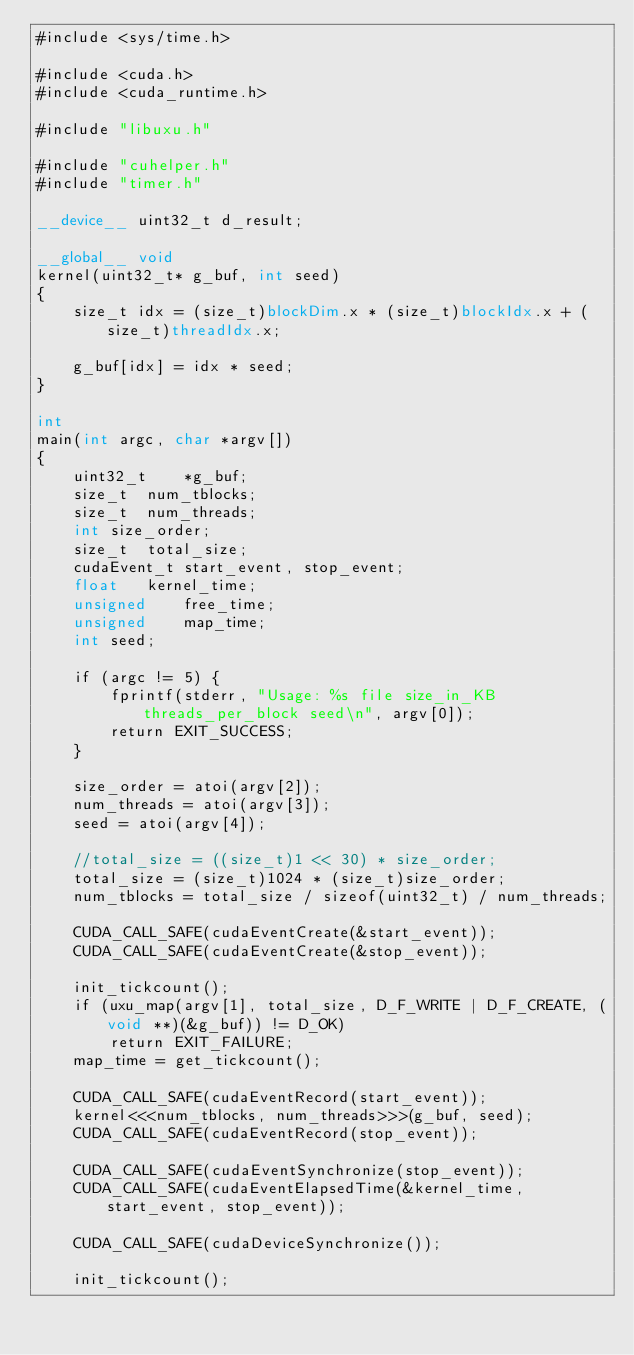<code> <loc_0><loc_0><loc_500><loc_500><_Cuda_>#include <sys/time.h>

#include <cuda.h>
#include <cuda_runtime.h>

#include "libuxu.h"

#include "cuhelper.h"
#include "timer.h"

__device__ uint32_t d_result;

__global__ void
kernel(uint32_t* g_buf, int seed) 
{
	size_t idx = (size_t)blockDim.x * (size_t)blockIdx.x + (size_t)threadIdx.x;

	g_buf[idx] = idx * seed;
}

int
main(int argc, char *argv[])
{
	uint32_t	*g_buf;
	size_t	num_tblocks;          
	size_t	num_threads;          
	int	size_order;
	size_t	total_size;
	cudaEvent_t	start_event, stop_event;
	float	kernel_time;
	unsigned	free_time;
	unsigned	map_time;
	int	seed;

	if (argc != 5) {
		fprintf(stderr, "Usage: %s file size_in_KB threads_per_block seed\n", argv[0]);
		return EXIT_SUCCESS;
	}

	size_order = atoi(argv[2]);
	num_threads = atoi(argv[3]);
	seed = atoi(argv[4]);
    
	//total_size = ((size_t)1 << 30) * size_order;
	total_size = (size_t)1024 * (size_t)size_order;
	num_tblocks = total_size / sizeof(uint32_t) / num_threads;
    
	CUDA_CALL_SAFE(cudaEventCreate(&start_event));
	CUDA_CALL_SAFE(cudaEventCreate(&stop_event));

	init_tickcount();
	if (uxu_map(argv[1], total_size, D_F_WRITE | D_F_CREATE, (void **)(&g_buf)) != D_OK)
		return EXIT_FAILURE;
	map_time = get_tickcount();

	CUDA_CALL_SAFE(cudaEventRecord(start_event));
	kernel<<<num_tblocks, num_threads>>>(g_buf, seed);
	CUDA_CALL_SAFE(cudaEventRecord(stop_event));

	CUDA_CALL_SAFE(cudaEventSynchronize(stop_event));
	CUDA_CALL_SAFE(cudaEventElapsedTime(&kernel_time, start_event, stop_event));

	CUDA_CALL_SAFE(cudaDeviceSynchronize());

	init_tickcount();</code> 